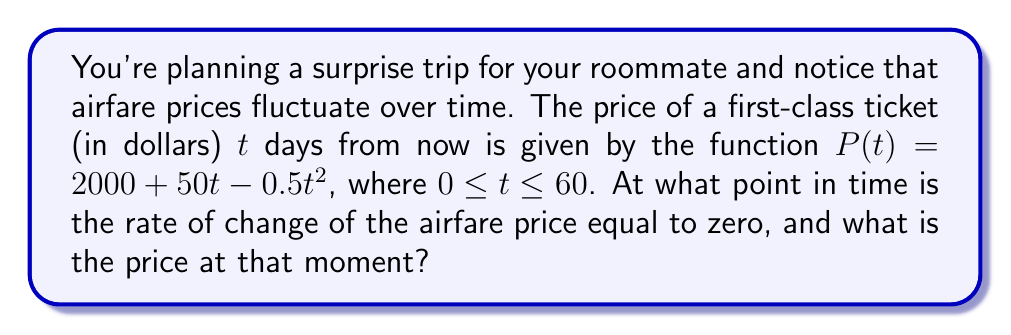Could you help me with this problem? To solve this problem, we need to follow these steps:

1) The rate of change of the airfare price is given by the derivative of $P(t)$. Let's find $P'(t)$:

   $$P'(t) = 50 - t$$

2) We want to find when this rate of change is zero:

   $$P'(t) = 0$$
   $$50 - t = 0$$
   $$t = 50$$

3) This means the rate of change is zero after 50 days.

4) To find the price at this point, we substitute $t = 50$ into the original function:

   $$P(50) = 2000 + 50(50) - 0.5(50)^2$$
   $$= 2000 + 2500 - 0.5(2500)$$
   $$= 2000 + 2500 - 1250$$
   $$= 3250$$

Therefore, the rate of change of the airfare price is zero after 50 days, and at that point, the price is $3250.
Answer: After 50 days; $3250 